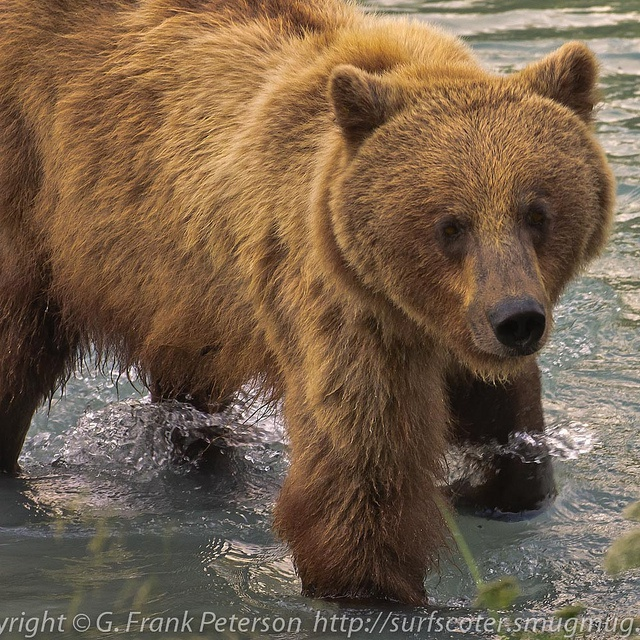Describe the objects in this image and their specific colors. I can see a bear in tan, maroon, gray, and black tones in this image. 